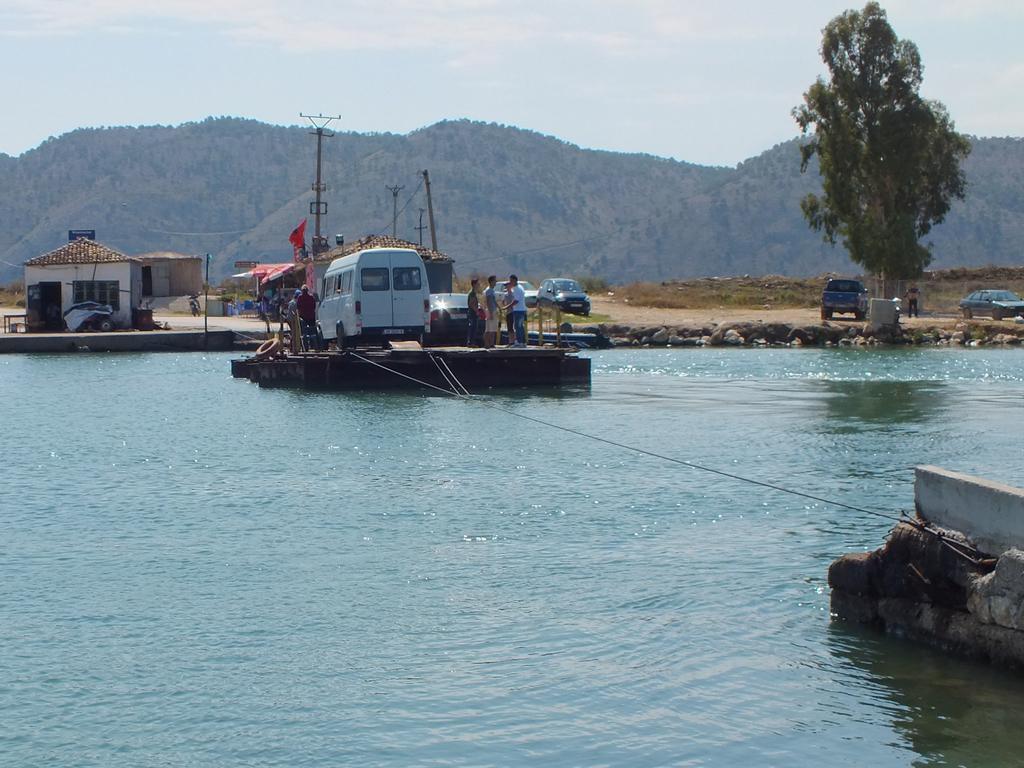Can you describe this image briefly? In this image I can see few people and few vehicles on the wooden surface and I can also see the water, few houses, vehicles, trees in green color and the sky is in blue and white color. 